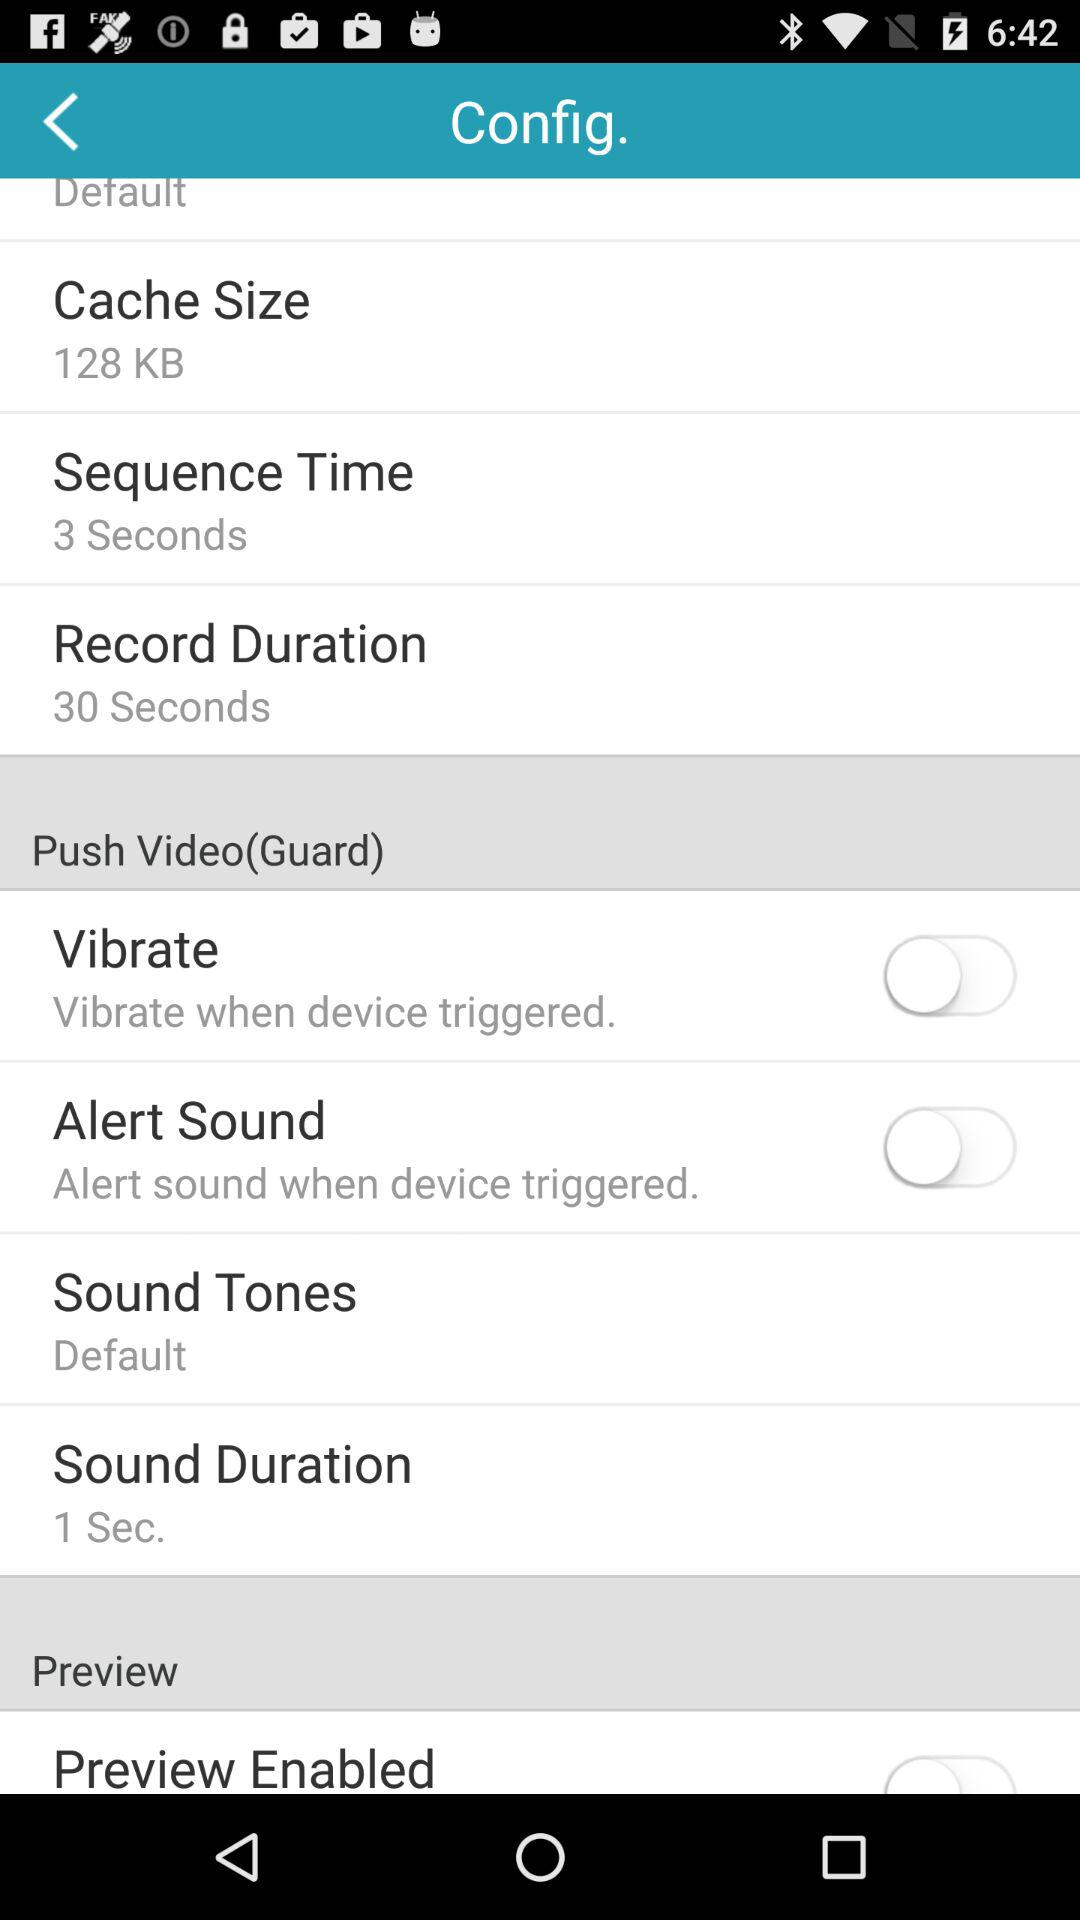What is the status of the vibrate? The status is "off". 